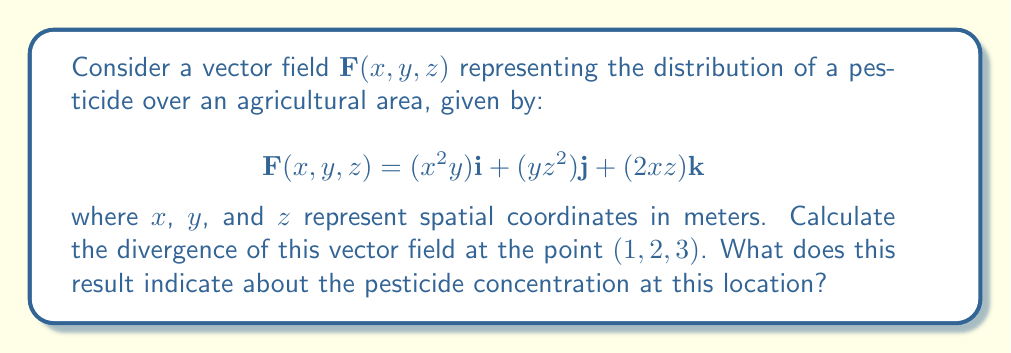Show me your answer to this math problem. To solve this problem, we'll follow these steps:

1) The divergence of a vector field $\mathbf{F}(x,y,z) = P\mathbf{i} + Q\mathbf{j} + R\mathbf{k}$ is given by:

   $$\nabla \cdot \mathbf{F} = \frac{\partial P}{\partial x} + \frac{\partial Q}{\partial y} + \frac{\partial R}{\partial z}$$

2) In our case:
   $P = x^2y$
   $Q = yz^2$
   $R = 2xz$

3) Let's calculate each partial derivative:

   $\frac{\partial P}{\partial x} = 2xy$
   
   $\frac{\partial Q}{\partial y} = z^2$
   
   $\frac{\partial R}{\partial z} = 2x$

4) Now, we sum these partial derivatives:

   $$\nabla \cdot \mathbf{F} = 2xy + z^2 + 2x$$

5) To find the divergence at the point (1,2,3), we substitute these values:

   $$\nabla \cdot \mathbf{F}(1,2,3) = 2(1)(2) + 3^2 + 2(1) = 4 + 9 + 2 = 15$$

6) Interpretation: The positive divergence indicates that this point is a source in the vector field. In the context of pesticide distribution, this suggests that at the point (1,2,3), there is a net outflow of pesticide, implying a higher concentration or application rate of the pesticide at this location.
Answer: $15$ m^2/s; source point with high pesticide concentration 